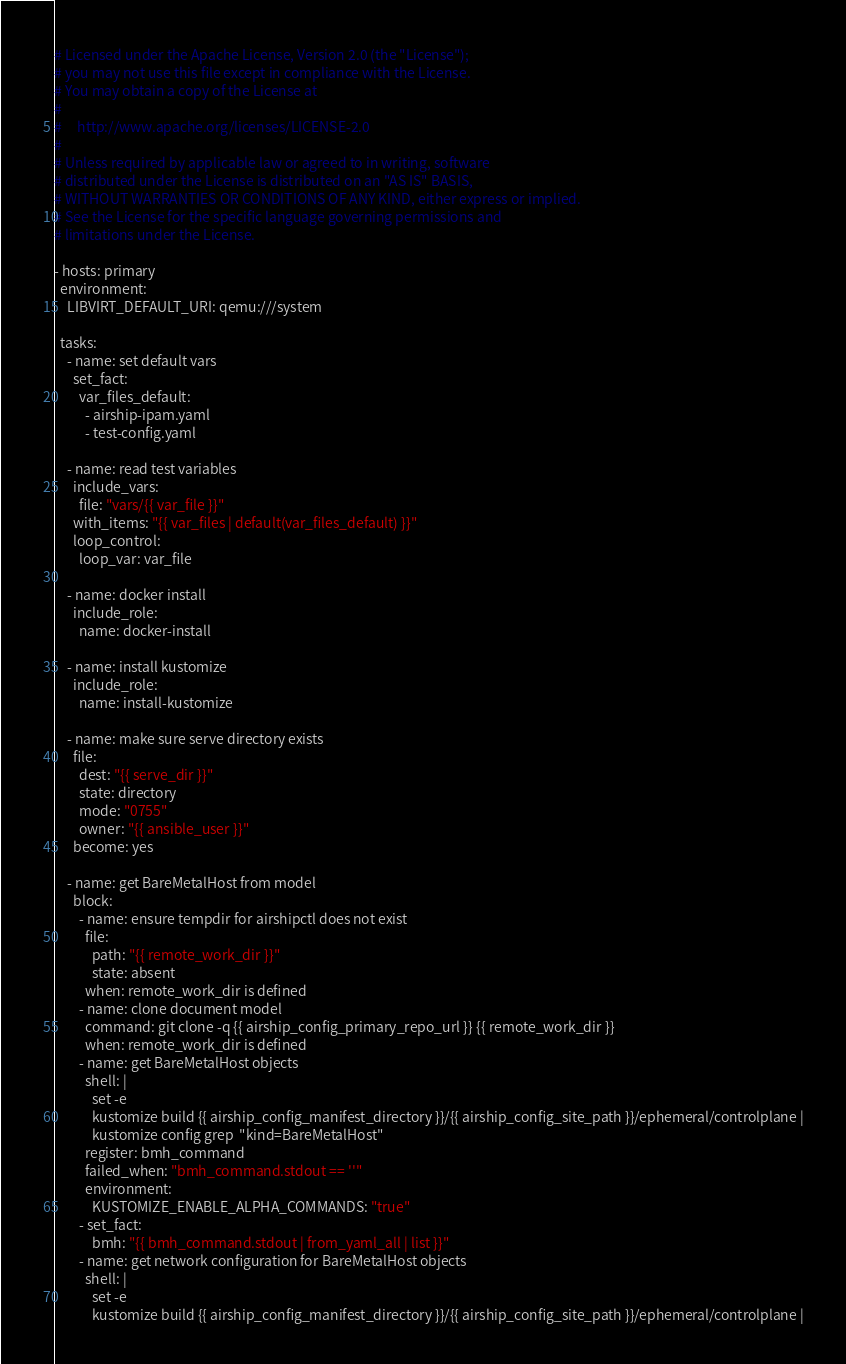<code> <loc_0><loc_0><loc_500><loc_500><_YAML_># Licensed under the Apache License, Version 2.0 (the "License");
# you may not use this file except in compliance with the License.
# You may obtain a copy of the License at
#
#     http://www.apache.org/licenses/LICENSE-2.0
#
# Unless required by applicable law or agreed to in writing, software
# distributed under the License is distributed on an "AS IS" BASIS,
# WITHOUT WARRANTIES OR CONDITIONS OF ANY KIND, either express or implied.
# See the License for the specific language governing permissions and
# limitations under the License.

- hosts: primary
  environment:
    LIBVIRT_DEFAULT_URI: qemu:///system

  tasks:
    - name: set default vars
      set_fact:
        var_files_default:
          - airship-ipam.yaml
          - test-config.yaml

    - name: read test variables
      include_vars:
        file: "vars/{{ var_file }}"
      with_items: "{{ var_files | default(var_files_default) }}"
      loop_control:
        loop_var: var_file

    - name: docker install
      include_role:
        name: docker-install

    - name: install kustomize
      include_role:
        name: install-kustomize

    - name: make sure serve directory exists
      file:
        dest: "{{ serve_dir }}"
        state: directory
        mode: "0755"
        owner: "{{ ansible_user }}"
      become: yes

    - name: get BareMetalHost from model
      block:
        - name: ensure tempdir for airshipctl does not exist
          file:
            path: "{{ remote_work_dir }}"
            state: absent
          when: remote_work_dir is defined
        - name: clone document model
          command: git clone -q {{ airship_config_primary_repo_url }} {{ remote_work_dir }}
          when: remote_work_dir is defined
        - name: get BareMetalHost objects
          shell: |
            set -e
            kustomize build {{ airship_config_manifest_directory }}/{{ airship_config_site_path }}/ephemeral/controlplane |
            kustomize config grep  "kind=BareMetalHost"
          register: bmh_command
          failed_when: "bmh_command.stdout == ''"
          environment:
            KUSTOMIZE_ENABLE_ALPHA_COMMANDS: "true"
        - set_fact:
            bmh: "{{ bmh_command.stdout | from_yaml_all | list }}"
        - name: get network configuration for BareMetalHost objects
          shell: |
            set -e
            kustomize build {{ airship_config_manifest_directory }}/{{ airship_config_site_path }}/ephemeral/controlplane |</code> 